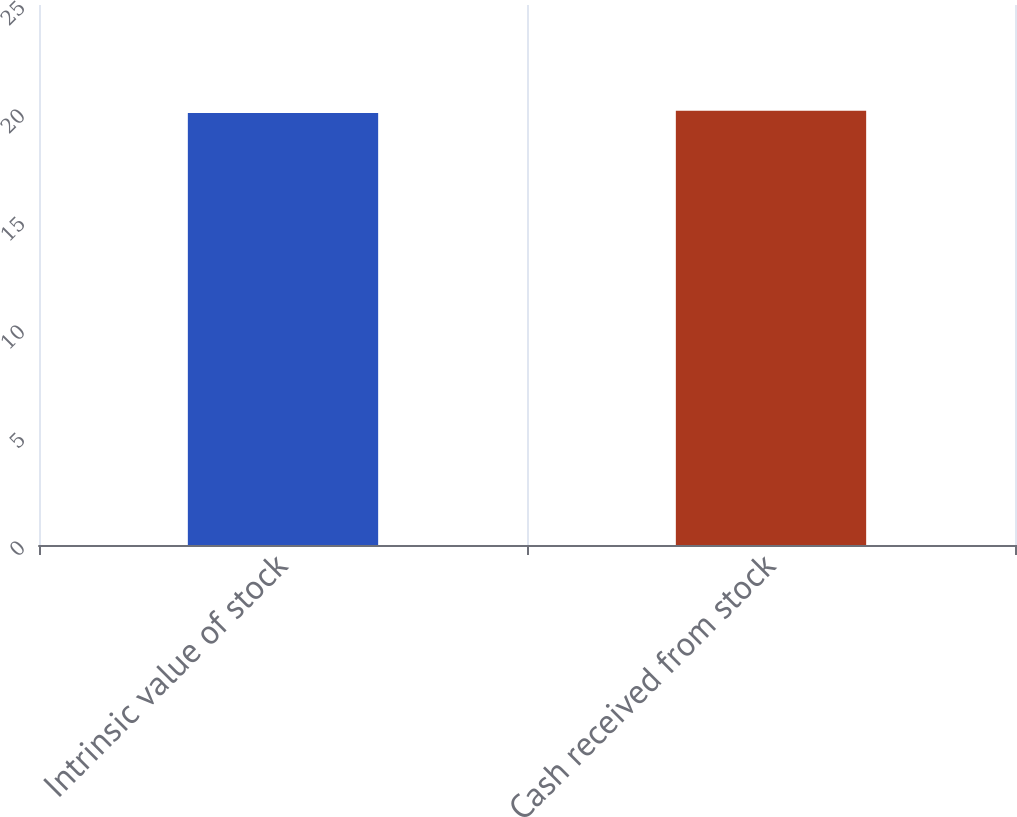Convert chart. <chart><loc_0><loc_0><loc_500><loc_500><bar_chart><fcel>Intrinsic value of stock<fcel>Cash received from stock<nl><fcel>20<fcel>20.1<nl></chart> 